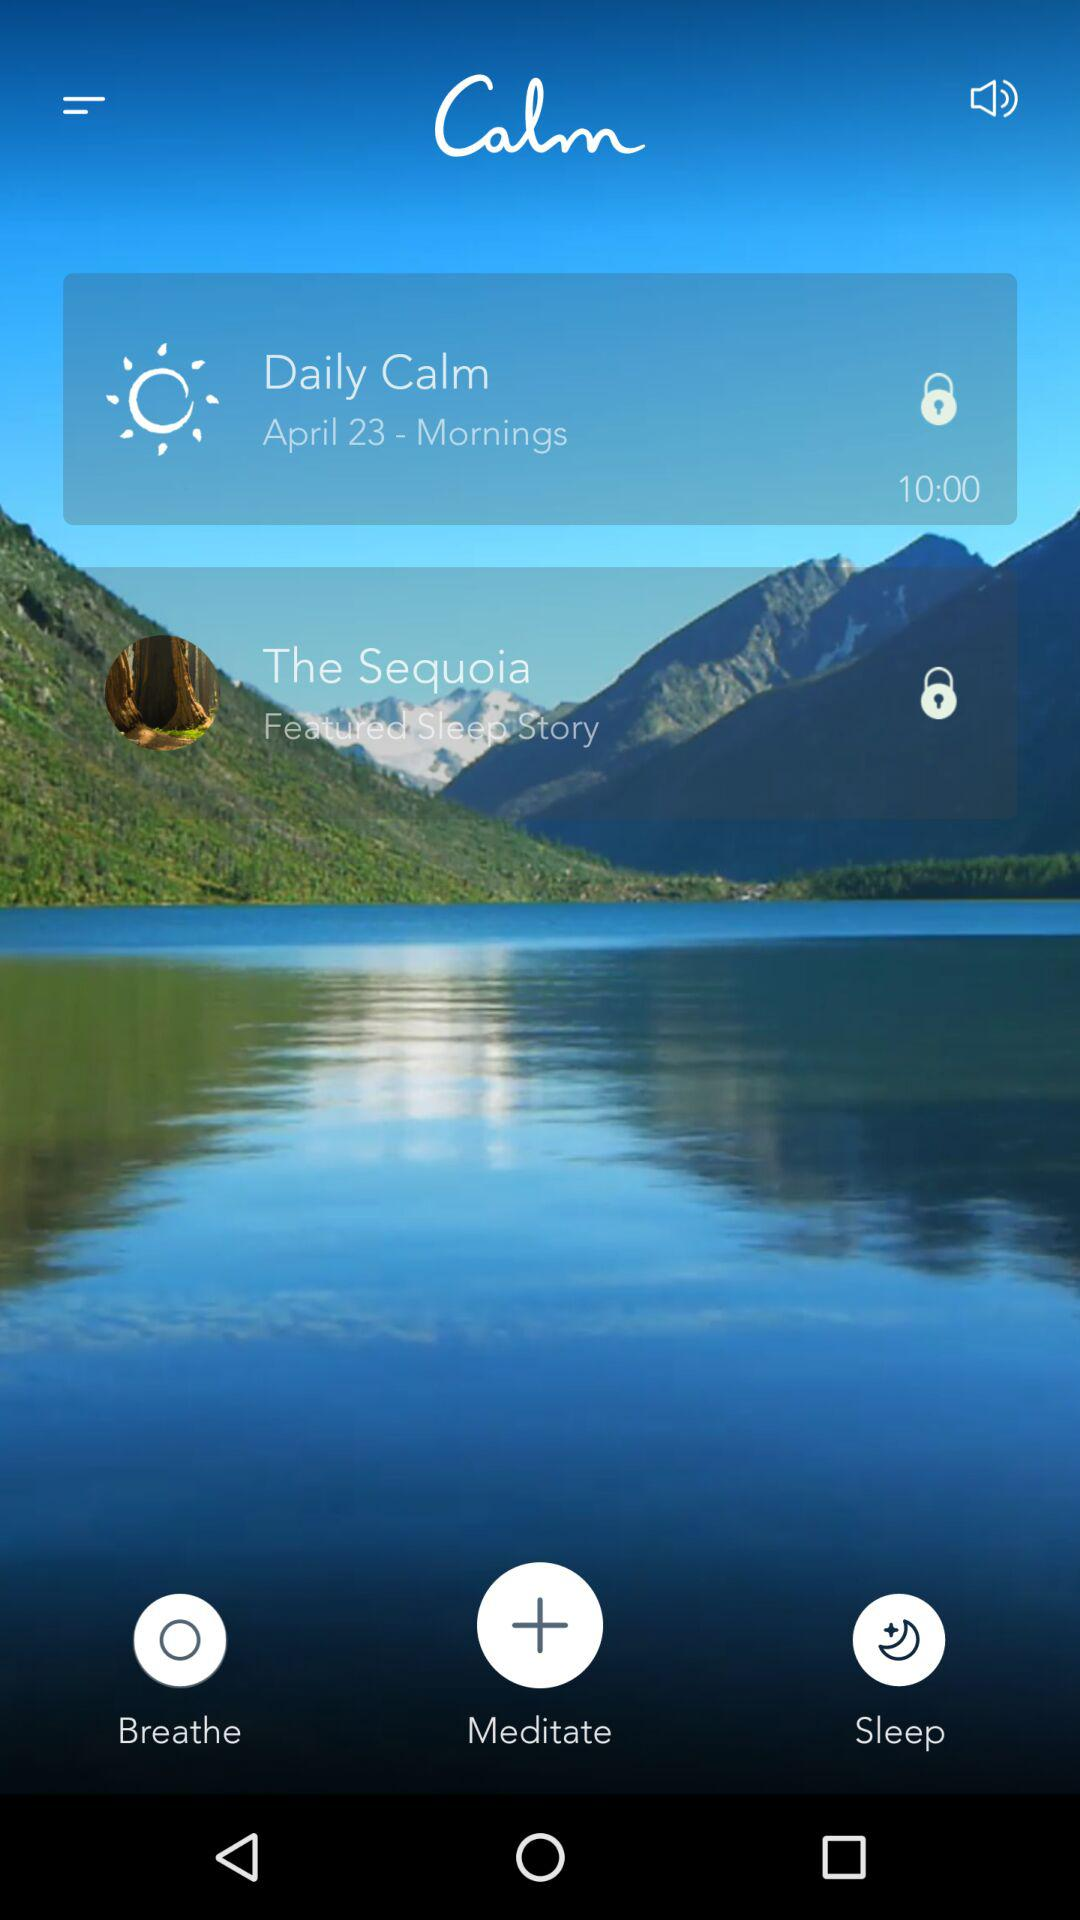What is the application name? The application name is "Calm". 